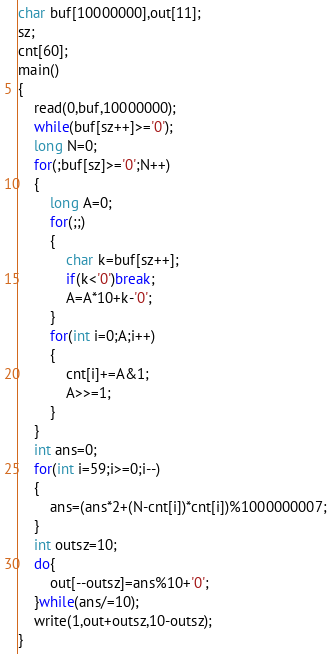Convert code to text. <code><loc_0><loc_0><loc_500><loc_500><_C_>char buf[10000000],out[11];
sz;
cnt[60];
main()
{
	read(0,buf,10000000);
	while(buf[sz++]>='0');
	long N=0;
	for(;buf[sz]>='0';N++)
	{
		long A=0;
		for(;;)
		{
			char k=buf[sz++];
			if(k<'0')break;
			A=A*10+k-'0';
		}
		for(int i=0;A;i++)
		{
			cnt[i]+=A&1;
			A>>=1;
		}
	}
	int ans=0;
	for(int i=59;i>=0;i--)
	{
		ans=(ans*2+(N-cnt[i])*cnt[i])%1000000007;
	}
	int outsz=10;
	do{
		out[--outsz]=ans%10+'0';
	}while(ans/=10);
	write(1,out+outsz,10-outsz);
}</code> 